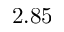<formula> <loc_0><loc_0><loc_500><loc_500>2 . 8 5</formula> 